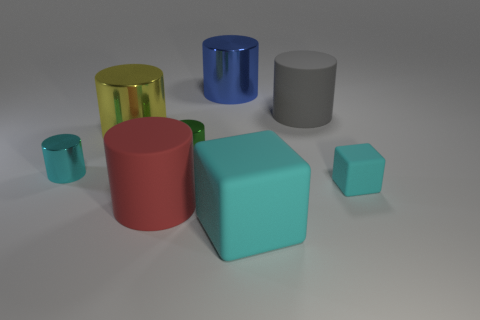Subtract all big blue cylinders. How many cylinders are left? 5 Subtract all yellow cylinders. How many cylinders are left? 5 Subtract all green cylinders. Subtract all red balls. How many cylinders are left? 5 Add 1 cyan balls. How many objects exist? 9 Subtract all cubes. How many objects are left? 6 Subtract all large blocks. Subtract all yellow rubber balls. How many objects are left? 7 Add 5 small cyan metallic cylinders. How many small cyan metallic cylinders are left? 6 Add 1 large red objects. How many large red objects exist? 2 Subtract 0 purple blocks. How many objects are left? 8 